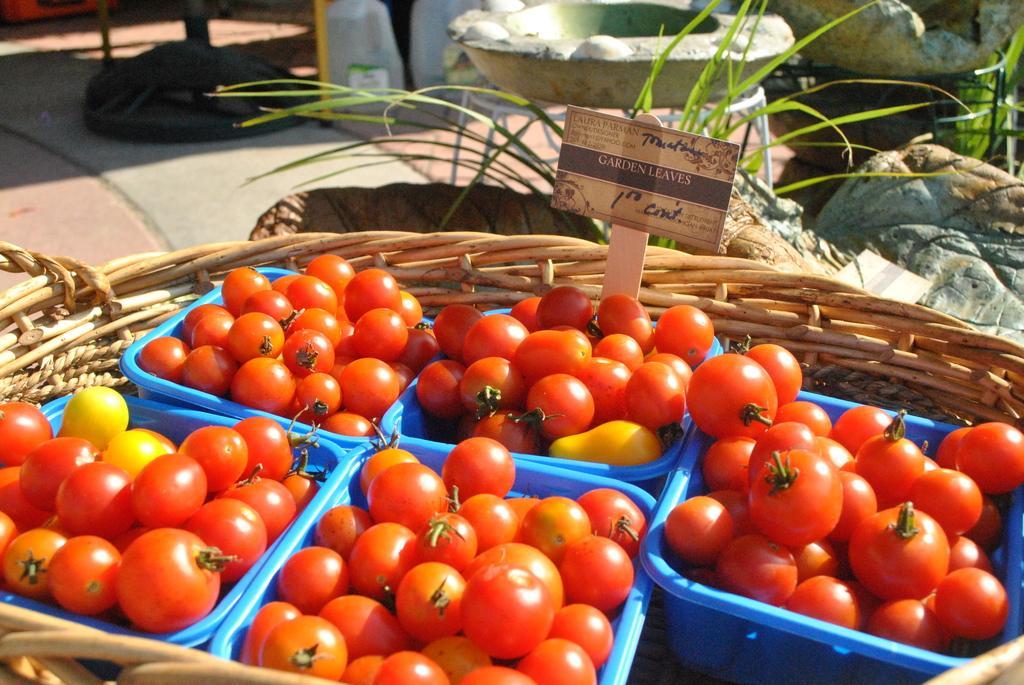How would you summarize this image in a sentence or two? In this picture, we see five blue baskets containing tomatoes are placed in the big basket. Beside that, we see the grass and rocks. This picture might be clicked in the market. 